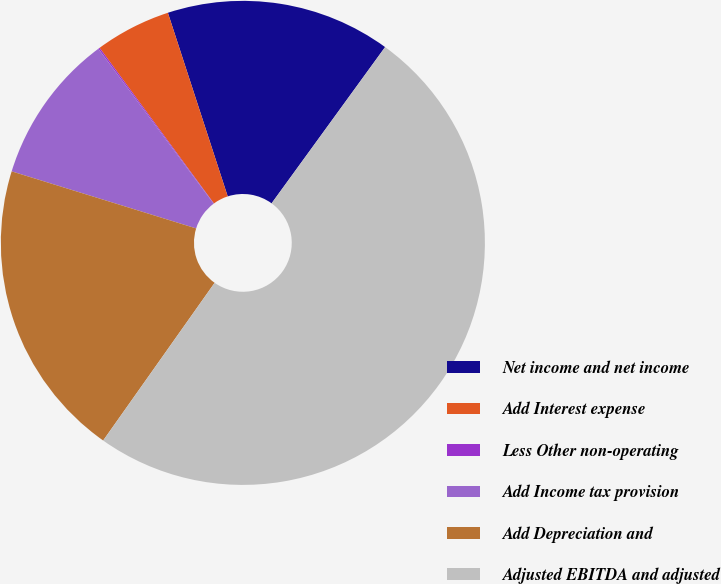<chart> <loc_0><loc_0><loc_500><loc_500><pie_chart><fcel>Net income and net income<fcel>Add Interest expense<fcel>Less Other non-operating<fcel>Add Income tax provision<fcel>Add Depreciation and<fcel>Adjusted EBITDA and adjusted<nl><fcel>15.01%<fcel>5.07%<fcel>0.1%<fcel>10.04%<fcel>19.98%<fcel>49.79%<nl></chart> 